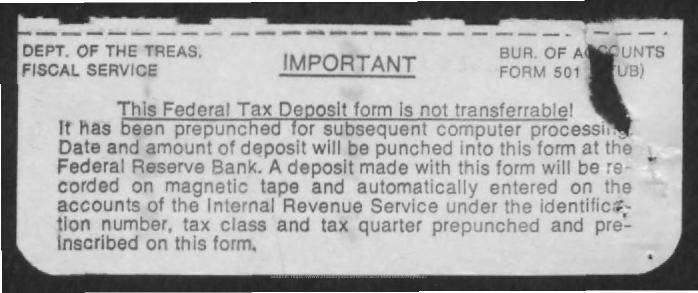Which department is involved?
Your answer should be very brief. DEPT. OF THE TREAS. 